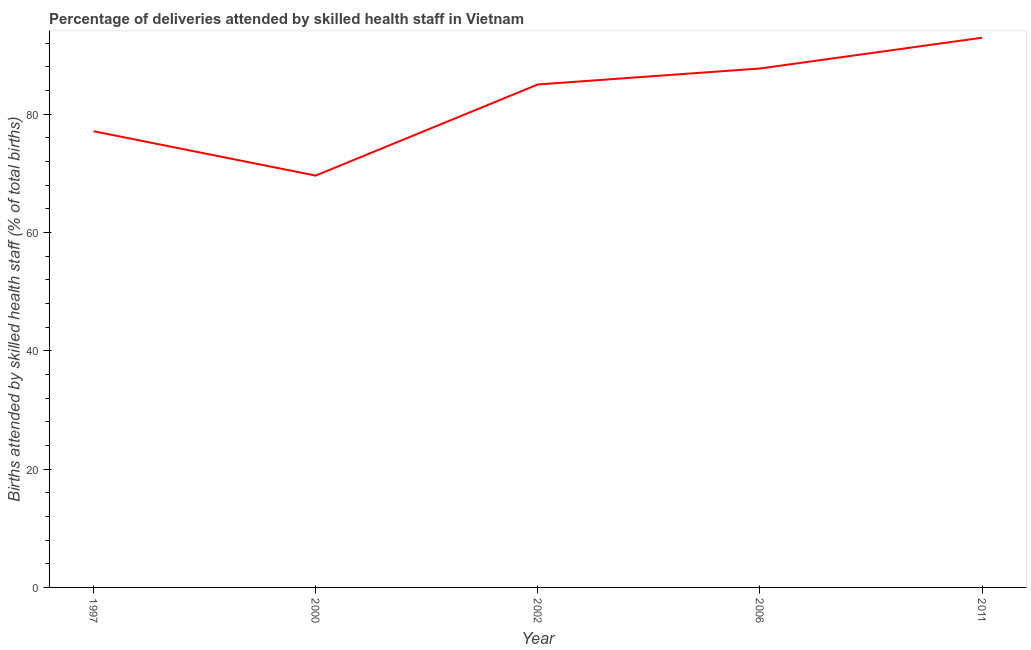What is the number of births attended by skilled health staff in 2011?
Make the answer very short. 92.9. Across all years, what is the maximum number of births attended by skilled health staff?
Provide a succinct answer. 92.9. Across all years, what is the minimum number of births attended by skilled health staff?
Ensure brevity in your answer.  69.6. In which year was the number of births attended by skilled health staff maximum?
Keep it short and to the point. 2011. In which year was the number of births attended by skilled health staff minimum?
Offer a very short reply. 2000. What is the sum of the number of births attended by skilled health staff?
Keep it short and to the point. 412.3. What is the difference between the number of births attended by skilled health staff in 1997 and 2000?
Provide a short and direct response. 7.5. What is the average number of births attended by skilled health staff per year?
Offer a terse response. 82.46. Do a majority of the years between 2000 and 2002 (inclusive) have number of births attended by skilled health staff greater than 8 %?
Your answer should be compact. Yes. What is the ratio of the number of births attended by skilled health staff in 2000 to that in 2011?
Your answer should be compact. 0.75. What is the difference between the highest and the second highest number of births attended by skilled health staff?
Your response must be concise. 5.2. What is the difference between the highest and the lowest number of births attended by skilled health staff?
Offer a very short reply. 23.3. In how many years, is the number of births attended by skilled health staff greater than the average number of births attended by skilled health staff taken over all years?
Make the answer very short. 3. Does the number of births attended by skilled health staff monotonically increase over the years?
Your answer should be very brief. No. How many lines are there?
Offer a terse response. 1. What is the difference between two consecutive major ticks on the Y-axis?
Provide a succinct answer. 20. Are the values on the major ticks of Y-axis written in scientific E-notation?
Your answer should be very brief. No. Does the graph contain any zero values?
Your answer should be very brief. No. What is the title of the graph?
Offer a terse response. Percentage of deliveries attended by skilled health staff in Vietnam. What is the label or title of the X-axis?
Ensure brevity in your answer.  Year. What is the label or title of the Y-axis?
Offer a very short reply. Births attended by skilled health staff (% of total births). What is the Births attended by skilled health staff (% of total births) in 1997?
Provide a short and direct response. 77.1. What is the Births attended by skilled health staff (% of total births) in 2000?
Give a very brief answer. 69.6. What is the Births attended by skilled health staff (% of total births) in 2006?
Your response must be concise. 87.7. What is the Births attended by skilled health staff (% of total births) in 2011?
Provide a short and direct response. 92.9. What is the difference between the Births attended by skilled health staff (% of total births) in 1997 and 2000?
Keep it short and to the point. 7.5. What is the difference between the Births attended by skilled health staff (% of total births) in 1997 and 2006?
Provide a short and direct response. -10.6. What is the difference between the Births attended by skilled health staff (% of total births) in 1997 and 2011?
Your answer should be very brief. -15.8. What is the difference between the Births attended by skilled health staff (% of total births) in 2000 and 2002?
Your answer should be compact. -15.4. What is the difference between the Births attended by skilled health staff (% of total births) in 2000 and 2006?
Give a very brief answer. -18.1. What is the difference between the Births attended by skilled health staff (% of total births) in 2000 and 2011?
Give a very brief answer. -23.3. What is the difference between the Births attended by skilled health staff (% of total births) in 2002 and 2011?
Ensure brevity in your answer.  -7.9. What is the difference between the Births attended by skilled health staff (% of total births) in 2006 and 2011?
Offer a very short reply. -5.2. What is the ratio of the Births attended by skilled health staff (% of total births) in 1997 to that in 2000?
Provide a succinct answer. 1.11. What is the ratio of the Births attended by skilled health staff (% of total births) in 1997 to that in 2002?
Your answer should be compact. 0.91. What is the ratio of the Births attended by skilled health staff (% of total births) in 1997 to that in 2006?
Ensure brevity in your answer.  0.88. What is the ratio of the Births attended by skilled health staff (% of total births) in 1997 to that in 2011?
Offer a terse response. 0.83. What is the ratio of the Births attended by skilled health staff (% of total births) in 2000 to that in 2002?
Give a very brief answer. 0.82. What is the ratio of the Births attended by skilled health staff (% of total births) in 2000 to that in 2006?
Keep it short and to the point. 0.79. What is the ratio of the Births attended by skilled health staff (% of total births) in 2000 to that in 2011?
Offer a very short reply. 0.75. What is the ratio of the Births attended by skilled health staff (% of total births) in 2002 to that in 2011?
Offer a terse response. 0.92. What is the ratio of the Births attended by skilled health staff (% of total births) in 2006 to that in 2011?
Provide a short and direct response. 0.94. 